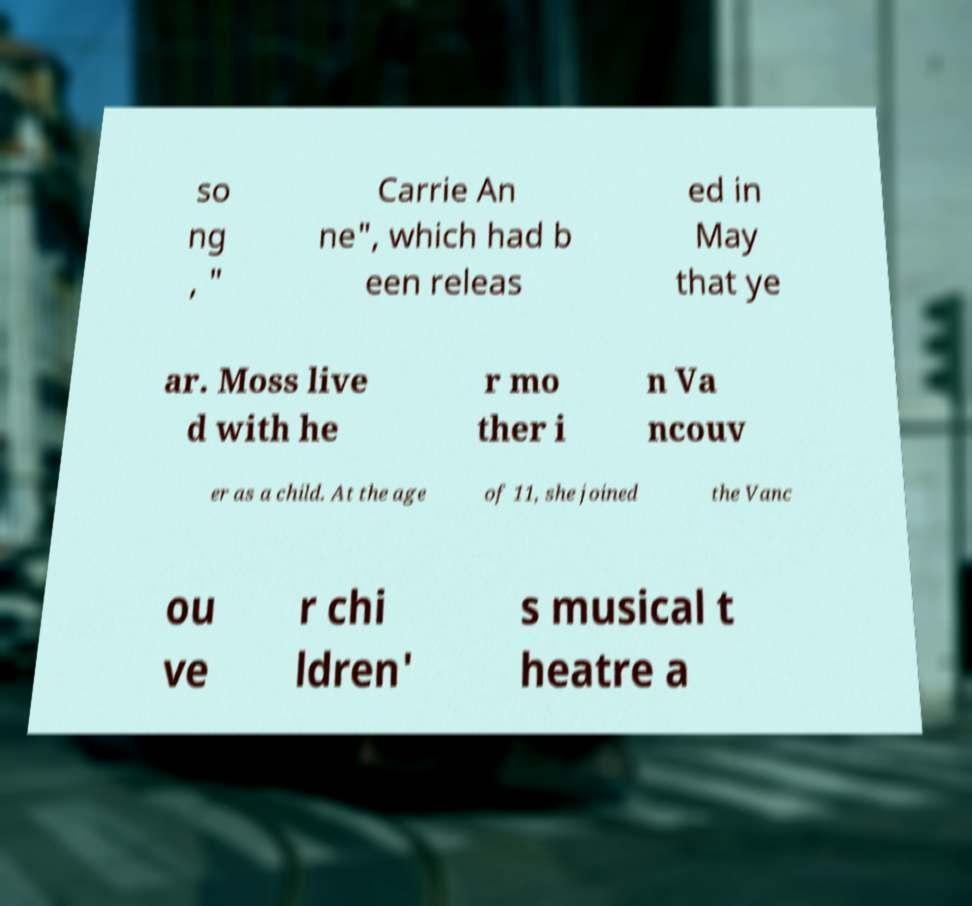There's text embedded in this image that I need extracted. Can you transcribe it verbatim? so ng , " Carrie An ne", which had b een releas ed in May that ye ar. Moss live d with he r mo ther i n Va ncouv er as a child. At the age of 11, she joined the Vanc ou ve r chi ldren' s musical t heatre a 